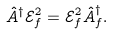Convert formula to latex. <formula><loc_0><loc_0><loc_500><loc_500>\hat { A } ^ { \dag } \mathcal { E } _ { f } ^ { 2 } = \mathcal { E } _ { f } ^ { 2 } \hat { A } _ { f } ^ { \dag } .</formula> 